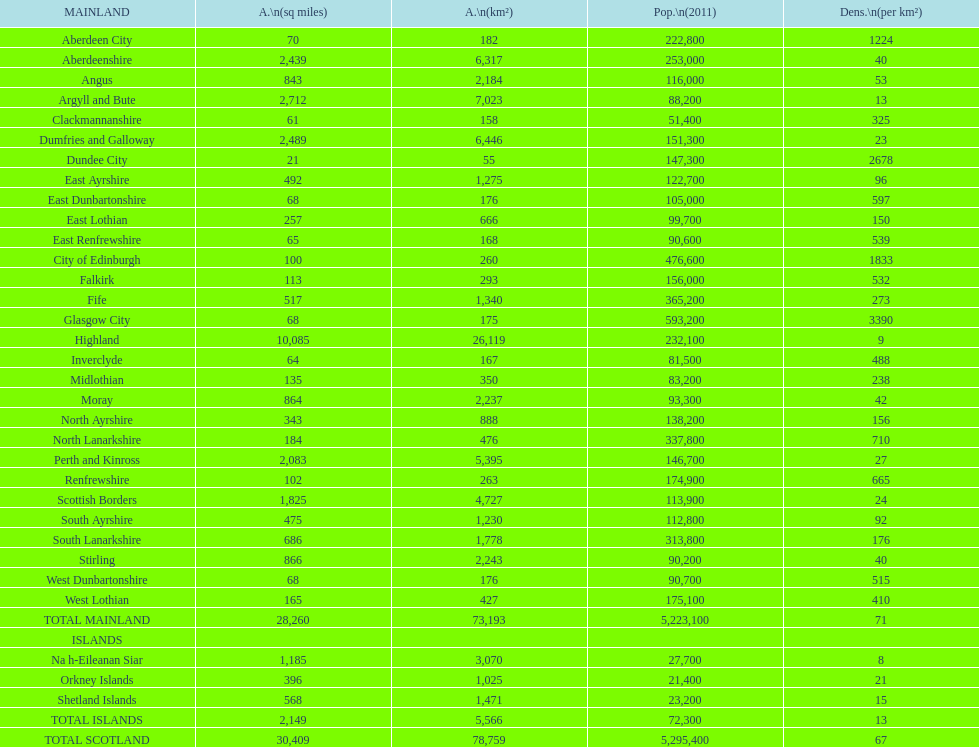If you were to organize the sites from the smallest to largest space, which one would be the initial one on the list? Dundee City. 